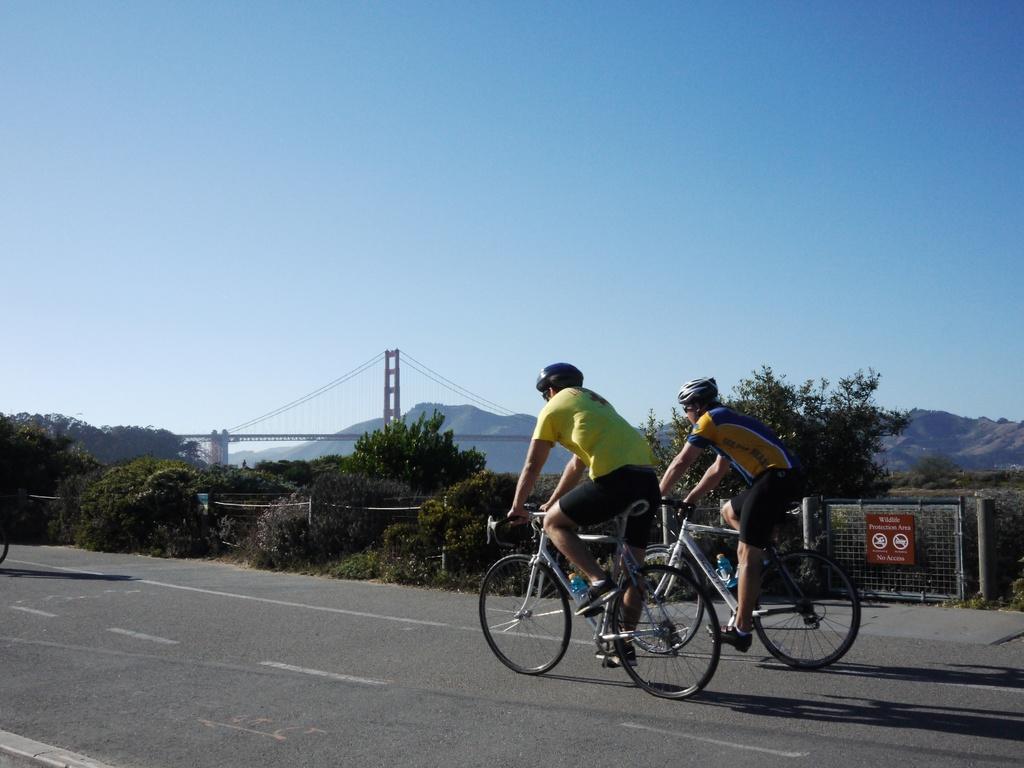Can you describe this image briefly? This is an outside view. Here I can see two men are riding their bicycles on the road. Both are wearing helmets on their heads. In the background, I can see some trees and a bridge. On the top of the image I can see the sky. 